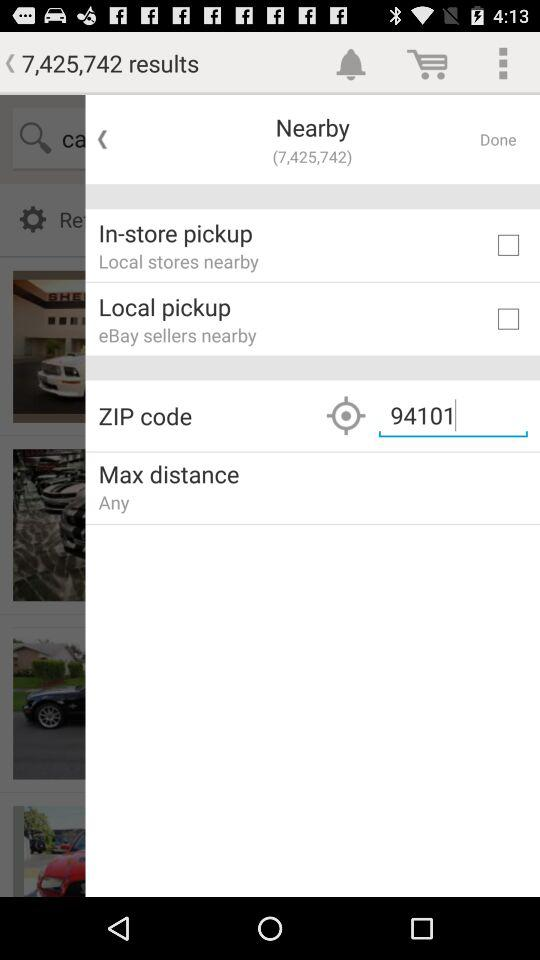How many results are there for the search query "ca"
Answer the question using a single word or phrase. 7,425,742 